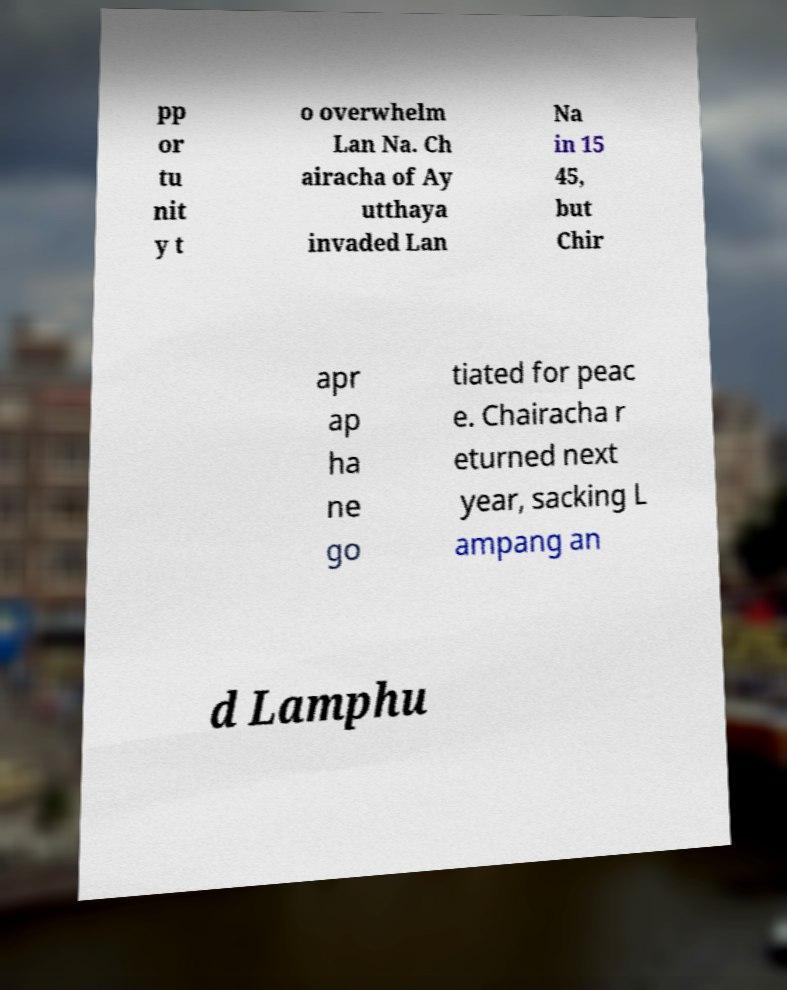I need the written content from this picture converted into text. Can you do that? pp or tu nit y t o overwhelm Lan Na. Ch airacha of Ay utthaya invaded Lan Na in 15 45, but Chir apr ap ha ne go tiated for peac e. Chairacha r eturned next year, sacking L ampang an d Lamphu 